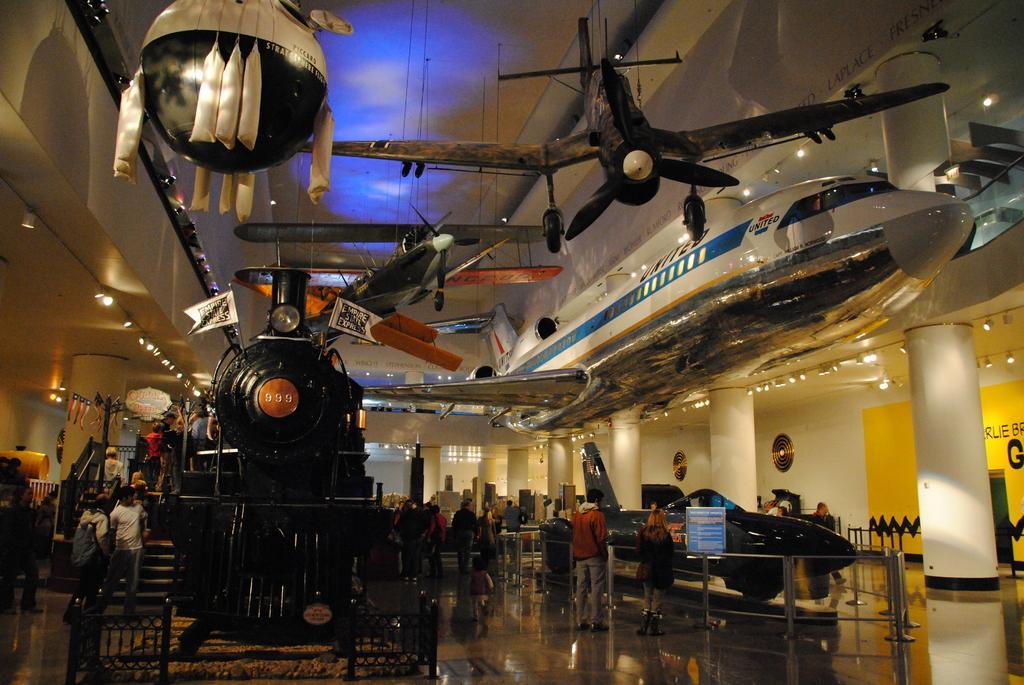Describe this image in one or two sentences. In this picture I can see there is a train engine and there are few air planes and few of them are attached to the ceiling and there is an air plane on here on the right. There are few stairs at the train engine and there are few people standing here. 